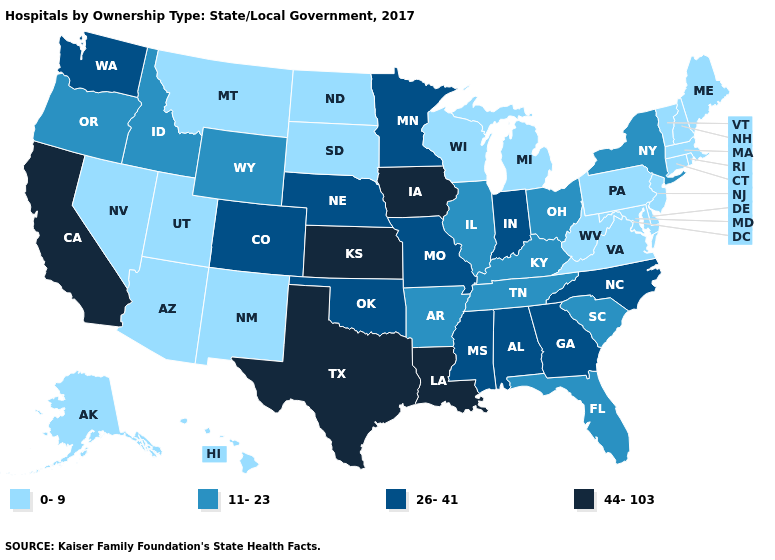Does Wisconsin have the lowest value in the MidWest?
Answer briefly. Yes. Name the states that have a value in the range 44-103?
Be succinct. California, Iowa, Kansas, Louisiana, Texas. Does Maryland have the lowest value in the USA?
Keep it brief. Yes. Does Alabama have a higher value than New Mexico?
Short answer required. Yes. Name the states that have a value in the range 11-23?
Give a very brief answer. Arkansas, Florida, Idaho, Illinois, Kentucky, New York, Ohio, Oregon, South Carolina, Tennessee, Wyoming. Does California have the highest value in the USA?
Be succinct. Yes. Does the map have missing data?
Answer briefly. No. What is the highest value in the Northeast ?
Keep it brief. 11-23. Does the map have missing data?
Concise answer only. No. What is the value of Delaware?
Be succinct. 0-9. Name the states that have a value in the range 26-41?
Concise answer only. Alabama, Colorado, Georgia, Indiana, Minnesota, Mississippi, Missouri, Nebraska, North Carolina, Oklahoma, Washington. What is the lowest value in the MidWest?
Be succinct. 0-9. Does Illinois have the lowest value in the USA?
Give a very brief answer. No. Which states have the lowest value in the Northeast?
Give a very brief answer. Connecticut, Maine, Massachusetts, New Hampshire, New Jersey, Pennsylvania, Rhode Island, Vermont. Does Nevada have the lowest value in the West?
Be succinct. Yes. 